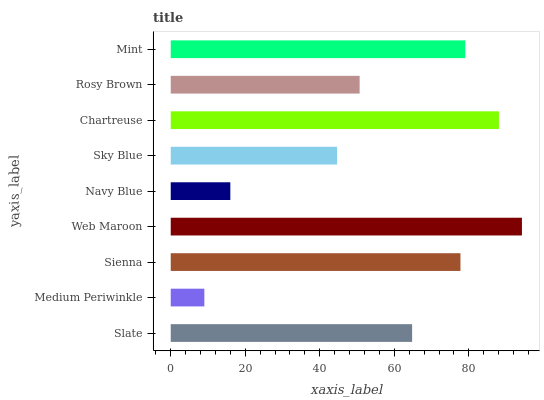Is Medium Periwinkle the minimum?
Answer yes or no. Yes. Is Web Maroon the maximum?
Answer yes or no. Yes. Is Sienna the minimum?
Answer yes or no. No. Is Sienna the maximum?
Answer yes or no. No. Is Sienna greater than Medium Periwinkle?
Answer yes or no. Yes. Is Medium Periwinkle less than Sienna?
Answer yes or no. Yes. Is Medium Periwinkle greater than Sienna?
Answer yes or no. No. Is Sienna less than Medium Periwinkle?
Answer yes or no. No. Is Slate the high median?
Answer yes or no. Yes. Is Slate the low median?
Answer yes or no. Yes. Is Web Maroon the high median?
Answer yes or no. No. Is Rosy Brown the low median?
Answer yes or no. No. 